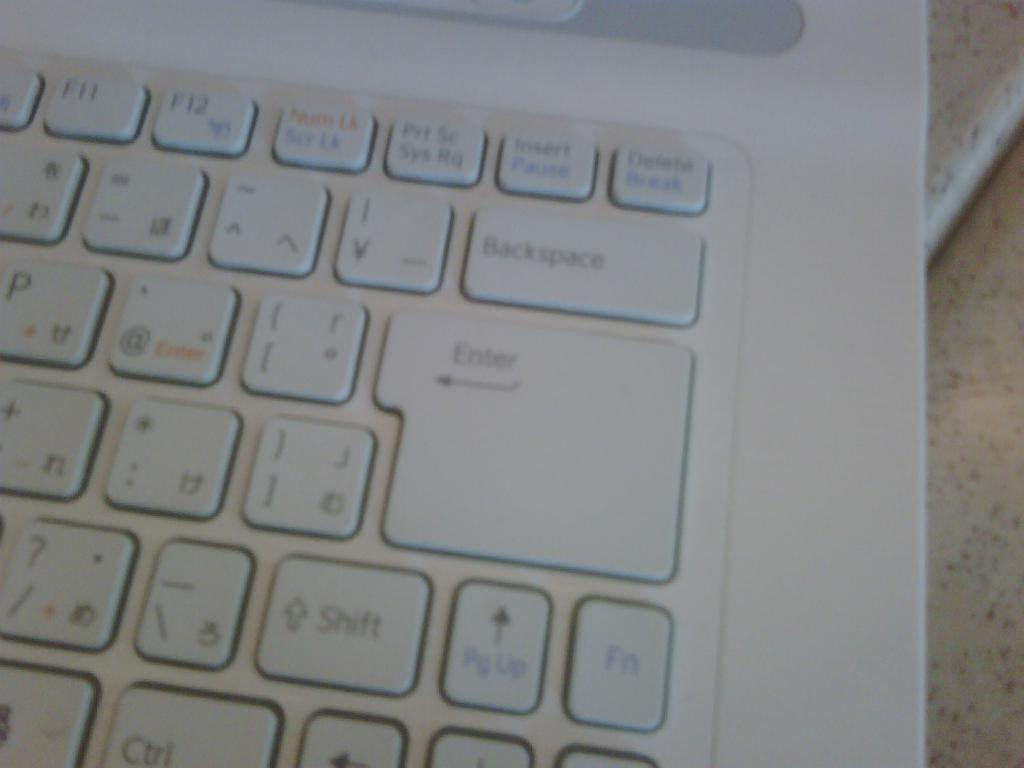<image>
Provide a brief description of the given image. a close up of a computer keyboard with keys such as Enter and FN 